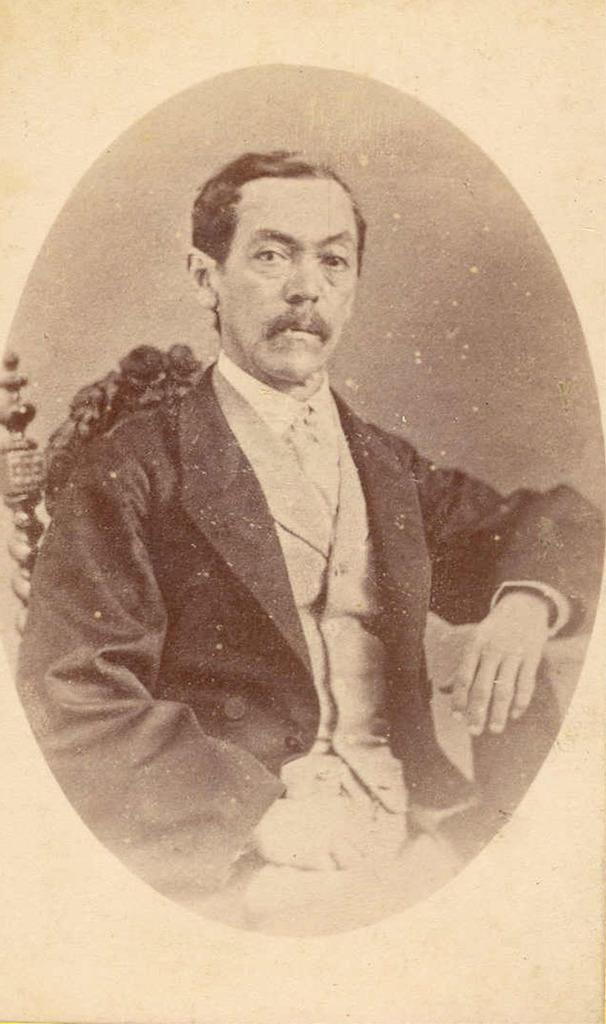What is the main subject of the image? There is a depiction of a man in the image. What is the man doing in the image? The man is sitting. What type of clothing is the man wearing in the image? The man is wearing a blazer, a shirt, and a waistcoat. What is the mass of the range in the image? There is no range present in the image, so it is not possible to determine its mass. 